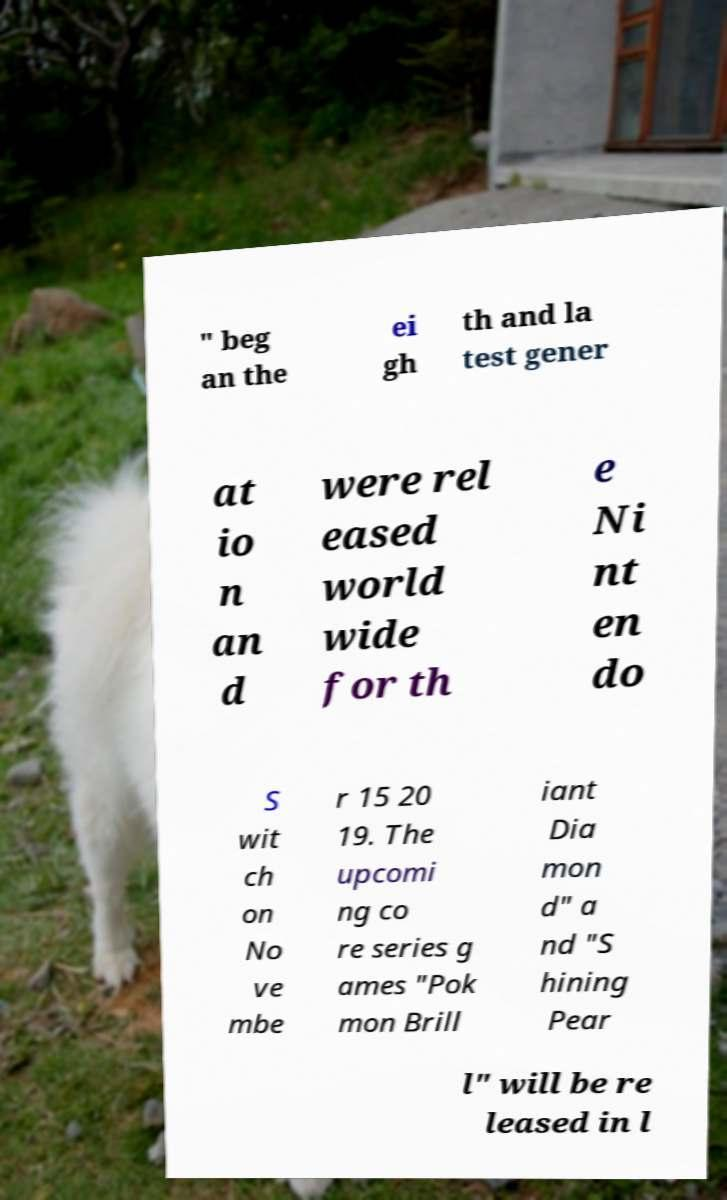Could you extract and type out the text from this image? " beg an the ei gh th and la test gener at io n an d were rel eased world wide for th e Ni nt en do S wit ch on No ve mbe r 15 20 19. The upcomi ng co re series g ames "Pok mon Brill iant Dia mon d" a nd "S hining Pear l" will be re leased in l 